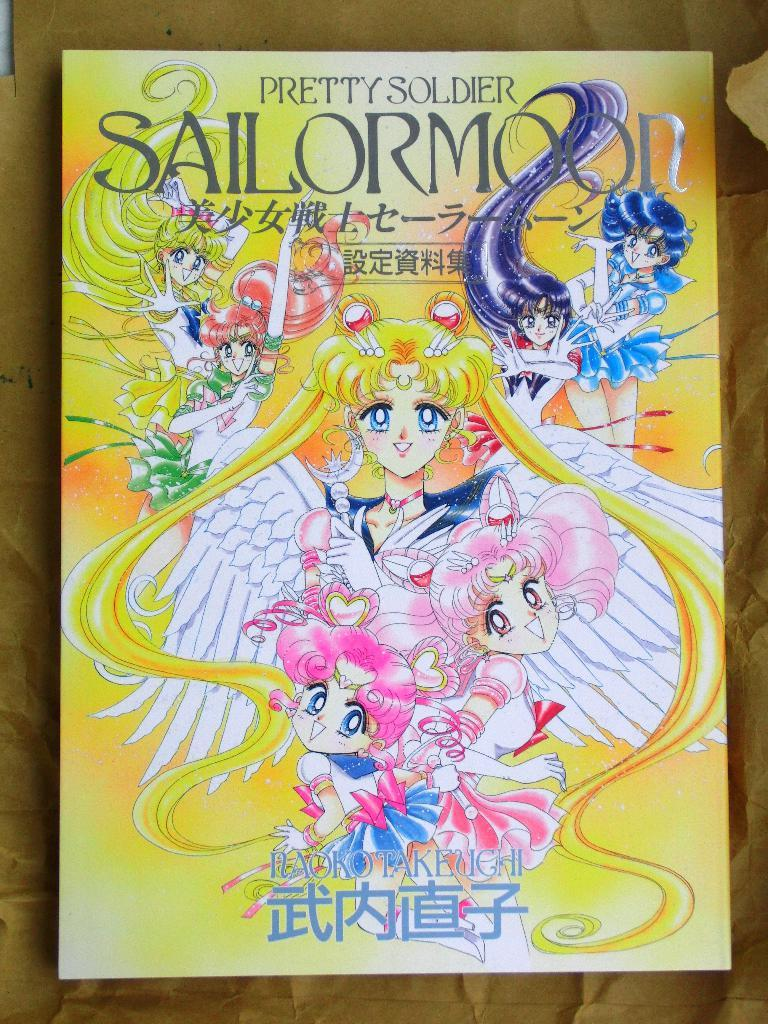Provide a one-sentence caption for the provided image. s book with the title Pretty Soldier at the top. 